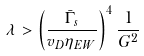<formula> <loc_0><loc_0><loc_500><loc_500>\lambda > \left ( \frac { { \bar { \Gamma } } _ { s } } { v _ { D } \eta _ { E W } } \right ) ^ { 4 } \frac { 1 } { G ^ { 2 } }</formula> 